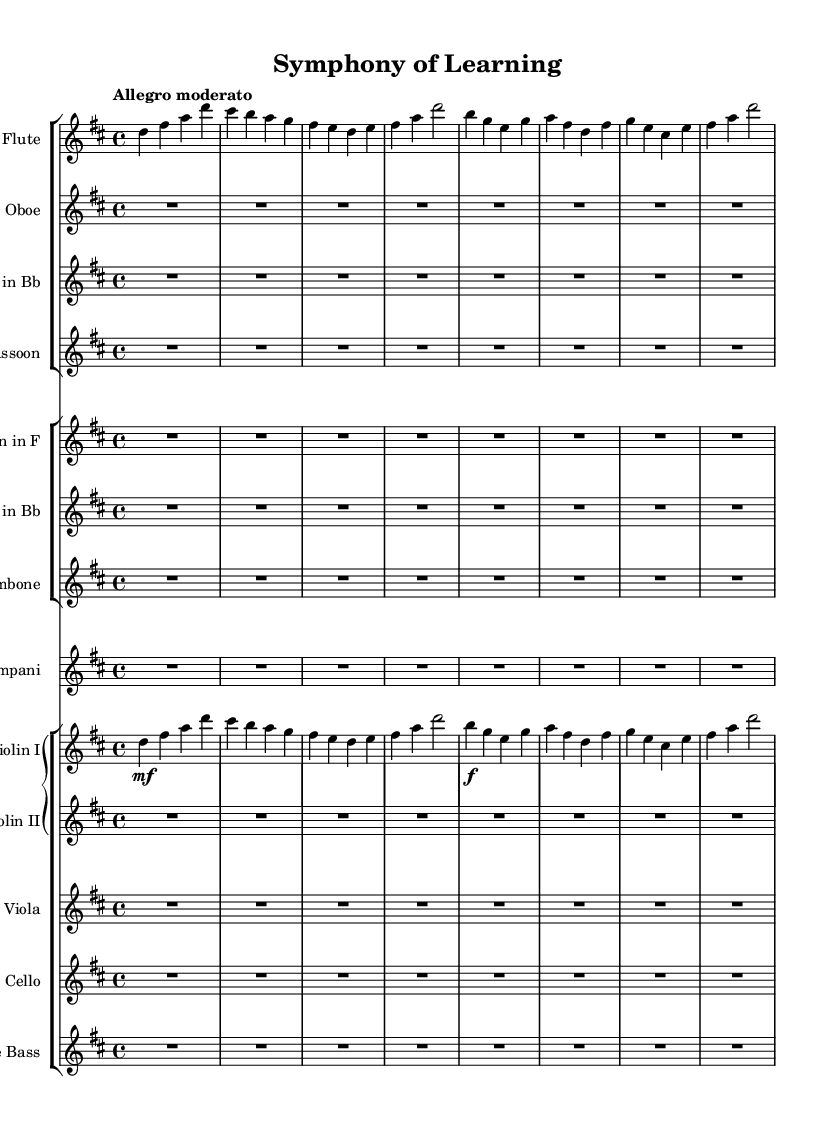What is the key signature of this music? The key signature shows two sharps, which indicates that the piece is in D major.
Answer: D major What is the time signature of this music? The time signature is indicated as 4/4, meaning there are four beats in a measure and the quarter note receives one beat.
Answer: 4/4 What is the tempo marking of the piece? The tempo marking states "Allegro moderato," indicating a moderately fast pace for the music.
Answer: Allegro moderato What is the dynamic marking for the first violin part? The first violin part starts with a marking of "mf," which means mezzo-forte or moderately loud.
Answer: mf Why is the oboe part marked with a rest for the entire measure? The oboe part has a whole measure rest (R1*8) indicating that the instrument does not play during this section, which can create a balance with other parts in the ensemble.
Answer: Whole rest How many different woodwind instruments are included in the orchestration? In the orchestration, there are four different woodwind instruments included: flute, oboe, clarinet, and bassoon.
Answer: Four Does the piece primarily use legato or staccato articulation, and how can you tell? The piece primarily uses legato articulation, indicated by the absence of staccato markings, suggesting a smooth and connected style throughout the phrases.
Answer: Legato 